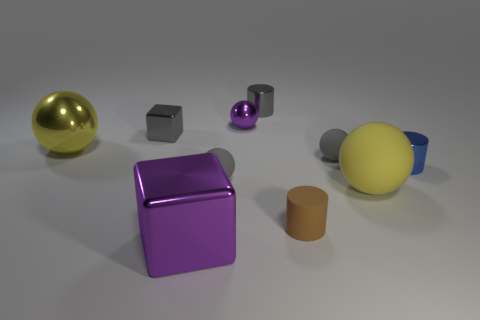Are any gray cubes visible?
Make the answer very short. Yes. Are the cylinder behind the yellow metal object and the yellow object left of the tiny brown cylinder made of the same material?
Make the answer very short. Yes. There is a object that is the same color as the large metal ball; what shape is it?
Provide a short and direct response. Sphere. What number of objects are either gray objects behind the yellow metallic object or objects that are behind the purple block?
Your answer should be compact. 9. Does the small metallic cylinder behind the small blue thing have the same color as the shiny cylinder that is in front of the gray cylinder?
Provide a short and direct response. No. There is a big object that is both behind the small rubber cylinder and to the right of the large metal ball; what shape is it?
Your answer should be very brief. Sphere. There is a shiny block that is the same size as the rubber cylinder; what is its color?
Your answer should be compact. Gray. Are there any tiny metallic objects that have the same color as the small shiny block?
Your answer should be very brief. Yes. There is a purple shiny object that is behind the big metal block; is it the same size as the purple object in front of the brown cylinder?
Your answer should be compact. No. What material is the tiny cylinder that is both in front of the gray metallic block and behind the big yellow rubber ball?
Provide a short and direct response. Metal. 